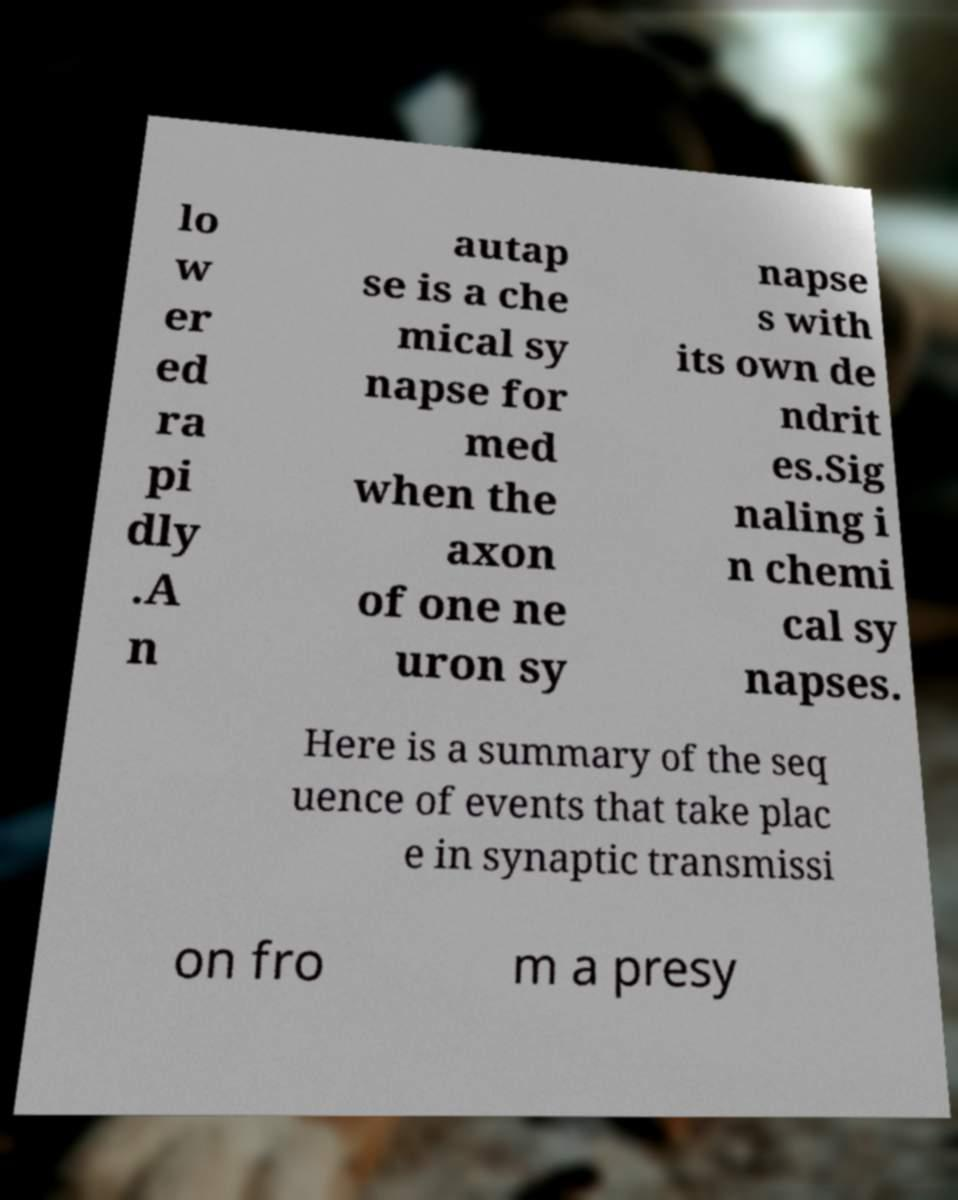Can you accurately transcribe the text from the provided image for me? lo w er ed ra pi dly .A n autap se is a che mical sy napse for med when the axon of one ne uron sy napse s with its own de ndrit es.Sig naling i n chemi cal sy napses. Here is a summary of the seq uence of events that take plac e in synaptic transmissi on fro m a presy 